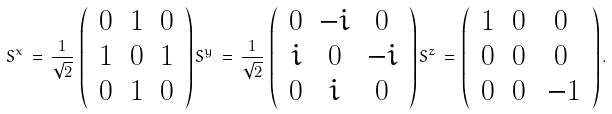Convert formula to latex. <formula><loc_0><loc_0><loc_500><loc_500>S ^ { x } \, = \, \frac { 1 } { \sqrt { 2 } } \, \left ( \, \begin{array} { c c c } 0 & 1 & 0 \\ 1 & 0 & 1 \\ 0 & 1 & 0 \end{array} \, \right ) S ^ { y } \, = \, \frac { 1 } { \sqrt { 2 } } \, \left ( \, \begin{array} { c c c } 0 & - i & 0 \\ i & 0 & - i \\ 0 & i & 0 \end{array} \, \right ) S ^ { z } \, = \, \left ( \, \begin{array} { c c c } 1 & 0 & 0 \\ 0 & 0 & 0 \\ 0 & 0 & \, - 1 \end{array} \, \right ) .</formula> 